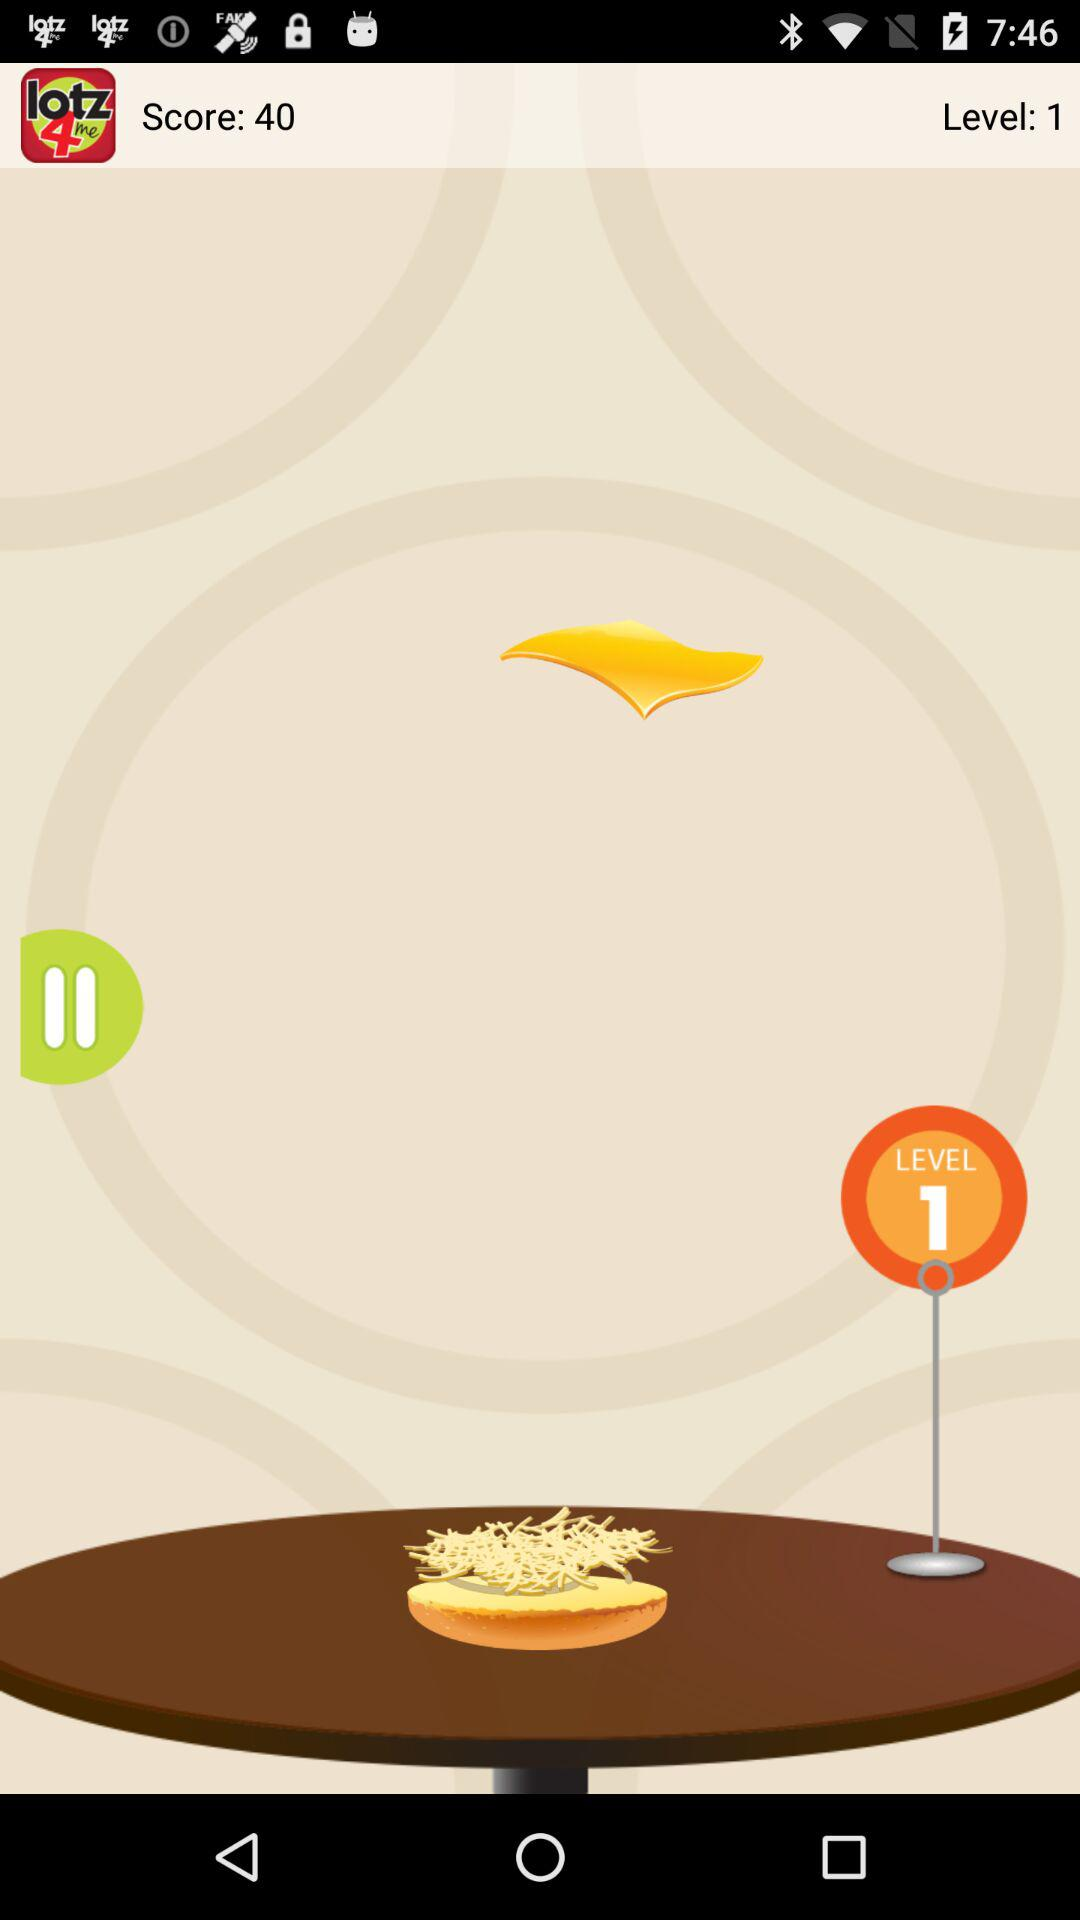What is the number of levels? The number of levels is 1. 